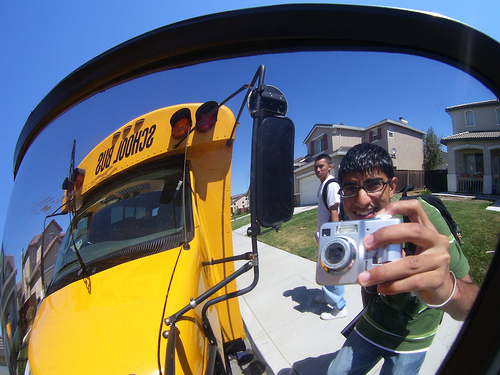Please provide the bounding box coordinate of the region this sentence describes: Man wearing green shirt. The bounding box for the region described by 'Man wearing green shirt' is [0.66, 0.41, 0.96, 0.87]. 